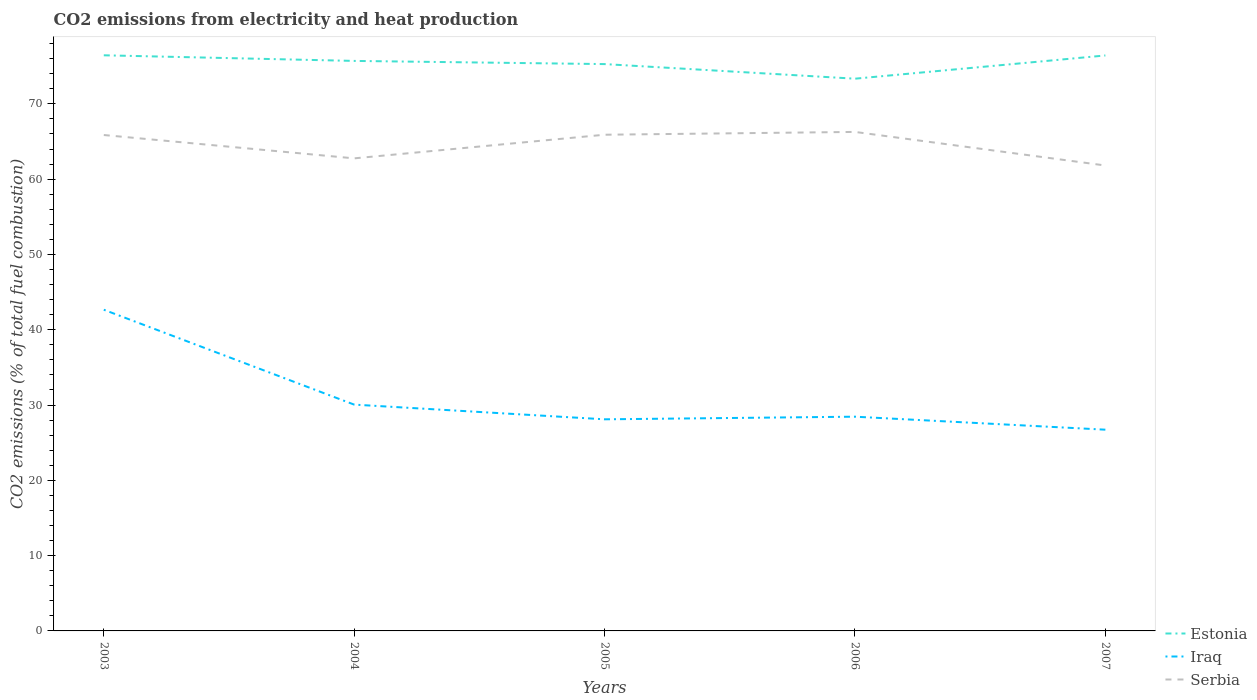How many different coloured lines are there?
Your answer should be very brief. 3. Does the line corresponding to Estonia intersect with the line corresponding to Serbia?
Offer a very short reply. No. Is the number of lines equal to the number of legend labels?
Offer a very short reply. Yes. Across all years, what is the maximum amount of CO2 emitted in Iraq?
Provide a short and direct response. 26.73. In which year was the amount of CO2 emitted in Iraq maximum?
Give a very brief answer. 2007. What is the total amount of CO2 emitted in Iraq in the graph?
Keep it short and to the point. 1.95. What is the difference between the highest and the second highest amount of CO2 emitted in Serbia?
Keep it short and to the point. 4.46. Is the amount of CO2 emitted in Iraq strictly greater than the amount of CO2 emitted in Estonia over the years?
Your response must be concise. Yes. How many years are there in the graph?
Give a very brief answer. 5. What is the difference between two consecutive major ticks on the Y-axis?
Your answer should be very brief. 10. Are the values on the major ticks of Y-axis written in scientific E-notation?
Provide a succinct answer. No. Does the graph contain any zero values?
Provide a short and direct response. No. Does the graph contain grids?
Make the answer very short. No. How are the legend labels stacked?
Offer a terse response. Vertical. What is the title of the graph?
Make the answer very short. CO2 emissions from electricity and heat production. Does "Azerbaijan" appear as one of the legend labels in the graph?
Give a very brief answer. No. What is the label or title of the Y-axis?
Offer a very short reply. CO2 emissions (% of total fuel combustion). What is the CO2 emissions (% of total fuel combustion) of Estonia in 2003?
Ensure brevity in your answer.  76.45. What is the CO2 emissions (% of total fuel combustion) in Iraq in 2003?
Your answer should be very brief. 42.66. What is the CO2 emissions (% of total fuel combustion) in Serbia in 2003?
Ensure brevity in your answer.  65.86. What is the CO2 emissions (% of total fuel combustion) in Estonia in 2004?
Make the answer very short. 75.7. What is the CO2 emissions (% of total fuel combustion) in Iraq in 2004?
Provide a short and direct response. 30.06. What is the CO2 emissions (% of total fuel combustion) in Serbia in 2004?
Make the answer very short. 62.76. What is the CO2 emissions (% of total fuel combustion) in Estonia in 2005?
Offer a terse response. 75.28. What is the CO2 emissions (% of total fuel combustion) of Iraq in 2005?
Your response must be concise. 28.1. What is the CO2 emissions (% of total fuel combustion) of Serbia in 2005?
Your answer should be very brief. 65.9. What is the CO2 emissions (% of total fuel combustion) of Estonia in 2006?
Give a very brief answer. 73.34. What is the CO2 emissions (% of total fuel combustion) in Iraq in 2006?
Make the answer very short. 28.45. What is the CO2 emissions (% of total fuel combustion) in Serbia in 2006?
Ensure brevity in your answer.  66.27. What is the CO2 emissions (% of total fuel combustion) of Estonia in 2007?
Your answer should be compact. 76.43. What is the CO2 emissions (% of total fuel combustion) in Iraq in 2007?
Your response must be concise. 26.73. What is the CO2 emissions (% of total fuel combustion) of Serbia in 2007?
Ensure brevity in your answer.  61.81. Across all years, what is the maximum CO2 emissions (% of total fuel combustion) of Estonia?
Provide a short and direct response. 76.45. Across all years, what is the maximum CO2 emissions (% of total fuel combustion) in Iraq?
Your answer should be compact. 42.66. Across all years, what is the maximum CO2 emissions (% of total fuel combustion) of Serbia?
Keep it short and to the point. 66.27. Across all years, what is the minimum CO2 emissions (% of total fuel combustion) in Estonia?
Ensure brevity in your answer.  73.34. Across all years, what is the minimum CO2 emissions (% of total fuel combustion) of Iraq?
Your response must be concise. 26.73. Across all years, what is the minimum CO2 emissions (% of total fuel combustion) in Serbia?
Offer a very short reply. 61.81. What is the total CO2 emissions (% of total fuel combustion) of Estonia in the graph?
Give a very brief answer. 377.2. What is the total CO2 emissions (% of total fuel combustion) in Iraq in the graph?
Keep it short and to the point. 156. What is the total CO2 emissions (% of total fuel combustion) in Serbia in the graph?
Your answer should be very brief. 322.61. What is the difference between the CO2 emissions (% of total fuel combustion) of Estonia in 2003 and that in 2004?
Offer a very short reply. 0.75. What is the difference between the CO2 emissions (% of total fuel combustion) of Iraq in 2003 and that in 2004?
Your answer should be compact. 12.6. What is the difference between the CO2 emissions (% of total fuel combustion) in Estonia in 2003 and that in 2005?
Ensure brevity in your answer.  1.17. What is the difference between the CO2 emissions (% of total fuel combustion) of Iraq in 2003 and that in 2005?
Your response must be concise. 14.55. What is the difference between the CO2 emissions (% of total fuel combustion) of Serbia in 2003 and that in 2005?
Provide a short and direct response. -0.04. What is the difference between the CO2 emissions (% of total fuel combustion) of Estonia in 2003 and that in 2006?
Provide a short and direct response. 3.11. What is the difference between the CO2 emissions (% of total fuel combustion) in Iraq in 2003 and that in 2006?
Make the answer very short. 14.21. What is the difference between the CO2 emissions (% of total fuel combustion) in Serbia in 2003 and that in 2006?
Offer a very short reply. -0.41. What is the difference between the CO2 emissions (% of total fuel combustion) of Estonia in 2003 and that in 2007?
Provide a succinct answer. 0.02. What is the difference between the CO2 emissions (% of total fuel combustion) of Iraq in 2003 and that in 2007?
Ensure brevity in your answer.  15.93. What is the difference between the CO2 emissions (% of total fuel combustion) in Serbia in 2003 and that in 2007?
Keep it short and to the point. 4.05. What is the difference between the CO2 emissions (% of total fuel combustion) of Estonia in 2004 and that in 2005?
Keep it short and to the point. 0.42. What is the difference between the CO2 emissions (% of total fuel combustion) of Iraq in 2004 and that in 2005?
Your response must be concise. 1.95. What is the difference between the CO2 emissions (% of total fuel combustion) in Serbia in 2004 and that in 2005?
Your answer should be compact. -3.14. What is the difference between the CO2 emissions (% of total fuel combustion) of Estonia in 2004 and that in 2006?
Offer a terse response. 2.36. What is the difference between the CO2 emissions (% of total fuel combustion) in Iraq in 2004 and that in 2006?
Your answer should be compact. 1.6. What is the difference between the CO2 emissions (% of total fuel combustion) of Serbia in 2004 and that in 2006?
Give a very brief answer. -3.51. What is the difference between the CO2 emissions (% of total fuel combustion) of Estonia in 2004 and that in 2007?
Provide a succinct answer. -0.72. What is the difference between the CO2 emissions (% of total fuel combustion) of Iraq in 2004 and that in 2007?
Provide a short and direct response. 3.33. What is the difference between the CO2 emissions (% of total fuel combustion) in Serbia in 2004 and that in 2007?
Your response must be concise. 0.95. What is the difference between the CO2 emissions (% of total fuel combustion) in Estonia in 2005 and that in 2006?
Keep it short and to the point. 1.94. What is the difference between the CO2 emissions (% of total fuel combustion) in Iraq in 2005 and that in 2006?
Offer a very short reply. -0.35. What is the difference between the CO2 emissions (% of total fuel combustion) of Serbia in 2005 and that in 2006?
Your response must be concise. -0.37. What is the difference between the CO2 emissions (% of total fuel combustion) of Estonia in 2005 and that in 2007?
Give a very brief answer. -1.15. What is the difference between the CO2 emissions (% of total fuel combustion) in Iraq in 2005 and that in 2007?
Give a very brief answer. 1.38. What is the difference between the CO2 emissions (% of total fuel combustion) in Serbia in 2005 and that in 2007?
Ensure brevity in your answer.  4.09. What is the difference between the CO2 emissions (% of total fuel combustion) of Estonia in 2006 and that in 2007?
Offer a very short reply. -3.09. What is the difference between the CO2 emissions (% of total fuel combustion) in Iraq in 2006 and that in 2007?
Offer a terse response. 1.73. What is the difference between the CO2 emissions (% of total fuel combustion) in Serbia in 2006 and that in 2007?
Provide a succinct answer. 4.46. What is the difference between the CO2 emissions (% of total fuel combustion) in Estonia in 2003 and the CO2 emissions (% of total fuel combustion) in Iraq in 2004?
Your answer should be very brief. 46.39. What is the difference between the CO2 emissions (% of total fuel combustion) in Estonia in 2003 and the CO2 emissions (% of total fuel combustion) in Serbia in 2004?
Offer a very short reply. 13.69. What is the difference between the CO2 emissions (% of total fuel combustion) of Iraq in 2003 and the CO2 emissions (% of total fuel combustion) of Serbia in 2004?
Give a very brief answer. -20.1. What is the difference between the CO2 emissions (% of total fuel combustion) of Estonia in 2003 and the CO2 emissions (% of total fuel combustion) of Iraq in 2005?
Your answer should be very brief. 48.35. What is the difference between the CO2 emissions (% of total fuel combustion) in Estonia in 2003 and the CO2 emissions (% of total fuel combustion) in Serbia in 2005?
Give a very brief answer. 10.55. What is the difference between the CO2 emissions (% of total fuel combustion) in Iraq in 2003 and the CO2 emissions (% of total fuel combustion) in Serbia in 2005?
Your answer should be compact. -23.24. What is the difference between the CO2 emissions (% of total fuel combustion) of Estonia in 2003 and the CO2 emissions (% of total fuel combustion) of Iraq in 2006?
Your answer should be very brief. 48. What is the difference between the CO2 emissions (% of total fuel combustion) of Estonia in 2003 and the CO2 emissions (% of total fuel combustion) of Serbia in 2006?
Your answer should be very brief. 10.18. What is the difference between the CO2 emissions (% of total fuel combustion) of Iraq in 2003 and the CO2 emissions (% of total fuel combustion) of Serbia in 2006?
Keep it short and to the point. -23.61. What is the difference between the CO2 emissions (% of total fuel combustion) in Estonia in 2003 and the CO2 emissions (% of total fuel combustion) in Iraq in 2007?
Provide a succinct answer. 49.72. What is the difference between the CO2 emissions (% of total fuel combustion) of Estonia in 2003 and the CO2 emissions (% of total fuel combustion) of Serbia in 2007?
Your response must be concise. 14.64. What is the difference between the CO2 emissions (% of total fuel combustion) in Iraq in 2003 and the CO2 emissions (% of total fuel combustion) in Serbia in 2007?
Keep it short and to the point. -19.15. What is the difference between the CO2 emissions (% of total fuel combustion) of Estonia in 2004 and the CO2 emissions (% of total fuel combustion) of Iraq in 2005?
Your answer should be compact. 47.6. What is the difference between the CO2 emissions (% of total fuel combustion) of Estonia in 2004 and the CO2 emissions (% of total fuel combustion) of Serbia in 2005?
Ensure brevity in your answer.  9.8. What is the difference between the CO2 emissions (% of total fuel combustion) in Iraq in 2004 and the CO2 emissions (% of total fuel combustion) in Serbia in 2005?
Offer a terse response. -35.84. What is the difference between the CO2 emissions (% of total fuel combustion) in Estonia in 2004 and the CO2 emissions (% of total fuel combustion) in Iraq in 2006?
Provide a succinct answer. 47.25. What is the difference between the CO2 emissions (% of total fuel combustion) of Estonia in 2004 and the CO2 emissions (% of total fuel combustion) of Serbia in 2006?
Your answer should be very brief. 9.43. What is the difference between the CO2 emissions (% of total fuel combustion) in Iraq in 2004 and the CO2 emissions (% of total fuel combustion) in Serbia in 2006?
Your answer should be compact. -36.22. What is the difference between the CO2 emissions (% of total fuel combustion) in Estonia in 2004 and the CO2 emissions (% of total fuel combustion) in Iraq in 2007?
Ensure brevity in your answer.  48.98. What is the difference between the CO2 emissions (% of total fuel combustion) of Estonia in 2004 and the CO2 emissions (% of total fuel combustion) of Serbia in 2007?
Give a very brief answer. 13.89. What is the difference between the CO2 emissions (% of total fuel combustion) of Iraq in 2004 and the CO2 emissions (% of total fuel combustion) of Serbia in 2007?
Offer a very short reply. -31.76. What is the difference between the CO2 emissions (% of total fuel combustion) of Estonia in 2005 and the CO2 emissions (% of total fuel combustion) of Iraq in 2006?
Ensure brevity in your answer.  46.83. What is the difference between the CO2 emissions (% of total fuel combustion) of Estonia in 2005 and the CO2 emissions (% of total fuel combustion) of Serbia in 2006?
Provide a short and direct response. 9.01. What is the difference between the CO2 emissions (% of total fuel combustion) of Iraq in 2005 and the CO2 emissions (% of total fuel combustion) of Serbia in 2006?
Offer a terse response. -38.17. What is the difference between the CO2 emissions (% of total fuel combustion) in Estonia in 2005 and the CO2 emissions (% of total fuel combustion) in Iraq in 2007?
Offer a terse response. 48.55. What is the difference between the CO2 emissions (% of total fuel combustion) of Estonia in 2005 and the CO2 emissions (% of total fuel combustion) of Serbia in 2007?
Your response must be concise. 13.47. What is the difference between the CO2 emissions (% of total fuel combustion) of Iraq in 2005 and the CO2 emissions (% of total fuel combustion) of Serbia in 2007?
Give a very brief answer. -33.71. What is the difference between the CO2 emissions (% of total fuel combustion) of Estonia in 2006 and the CO2 emissions (% of total fuel combustion) of Iraq in 2007?
Your response must be concise. 46.62. What is the difference between the CO2 emissions (% of total fuel combustion) of Estonia in 2006 and the CO2 emissions (% of total fuel combustion) of Serbia in 2007?
Your answer should be very brief. 11.53. What is the difference between the CO2 emissions (% of total fuel combustion) of Iraq in 2006 and the CO2 emissions (% of total fuel combustion) of Serbia in 2007?
Your answer should be compact. -33.36. What is the average CO2 emissions (% of total fuel combustion) in Estonia per year?
Keep it short and to the point. 75.44. What is the average CO2 emissions (% of total fuel combustion) in Iraq per year?
Give a very brief answer. 31.2. What is the average CO2 emissions (% of total fuel combustion) in Serbia per year?
Offer a very short reply. 64.52. In the year 2003, what is the difference between the CO2 emissions (% of total fuel combustion) of Estonia and CO2 emissions (% of total fuel combustion) of Iraq?
Your answer should be very brief. 33.79. In the year 2003, what is the difference between the CO2 emissions (% of total fuel combustion) of Estonia and CO2 emissions (% of total fuel combustion) of Serbia?
Provide a succinct answer. 10.59. In the year 2003, what is the difference between the CO2 emissions (% of total fuel combustion) in Iraq and CO2 emissions (% of total fuel combustion) in Serbia?
Provide a short and direct response. -23.2. In the year 2004, what is the difference between the CO2 emissions (% of total fuel combustion) of Estonia and CO2 emissions (% of total fuel combustion) of Iraq?
Keep it short and to the point. 45.65. In the year 2004, what is the difference between the CO2 emissions (% of total fuel combustion) in Estonia and CO2 emissions (% of total fuel combustion) in Serbia?
Provide a succinct answer. 12.94. In the year 2004, what is the difference between the CO2 emissions (% of total fuel combustion) of Iraq and CO2 emissions (% of total fuel combustion) of Serbia?
Your response must be concise. -32.71. In the year 2005, what is the difference between the CO2 emissions (% of total fuel combustion) of Estonia and CO2 emissions (% of total fuel combustion) of Iraq?
Your response must be concise. 47.18. In the year 2005, what is the difference between the CO2 emissions (% of total fuel combustion) in Estonia and CO2 emissions (% of total fuel combustion) in Serbia?
Keep it short and to the point. 9.38. In the year 2005, what is the difference between the CO2 emissions (% of total fuel combustion) in Iraq and CO2 emissions (% of total fuel combustion) in Serbia?
Give a very brief answer. -37.8. In the year 2006, what is the difference between the CO2 emissions (% of total fuel combustion) in Estonia and CO2 emissions (% of total fuel combustion) in Iraq?
Ensure brevity in your answer.  44.89. In the year 2006, what is the difference between the CO2 emissions (% of total fuel combustion) in Estonia and CO2 emissions (% of total fuel combustion) in Serbia?
Your response must be concise. 7.07. In the year 2006, what is the difference between the CO2 emissions (% of total fuel combustion) of Iraq and CO2 emissions (% of total fuel combustion) of Serbia?
Your answer should be compact. -37.82. In the year 2007, what is the difference between the CO2 emissions (% of total fuel combustion) of Estonia and CO2 emissions (% of total fuel combustion) of Iraq?
Your response must be concise. 49.7. In the year 2007, what is the difference between the CO2 emissions (% of total fuel combustion) in Estonia and CO2 emissions (% of total fuel combustion) in Serbia?
Provide a succinct answer. 14.62. In the year 2007, what is the difference between the CO2 emissions (% of total fuel combustion) of Iraq and CO2 emissions (% of total fuel combustion) of Serbia?
Offer a very short reply. -35.09. What is the ratio of the CO2 emissions (% of total fuel combustion) of Estonia in 2003 to that in 2004?
Provide a short and direct response. 1.01. What is the ratio of the CO2 emissions (% of total fuel combustion) in Iraq in 2003 to that in 2004?
Ensure brevity in your answer.  1.42. What is the ratio of the CO2 emissions (% of total fuel combustion) of Serbia in 2003 to that in 2004?
Ensure brevity in your answer.  1.05. What is the ratio of the CO2 emissions (% of total fuel combustion) of Estonia in 2003 to that in 2005?
Offer a very short reply. 1.02. What is the ratio of the CO2 emissions (% of total fuel combustion) in Iraq in 2003 to that in 2005?
Offer a very short reply. 1.52. What is the ratio of the CO2 emissions (% of total fuel combustion) in Serbia in 2003 to that in 2005?
Your response must be concise. 1. What is the ratio of the CO2 emissions (% of total fuel combustion) of Estonia in 2003 to that in 2006?
Provide a succinct answer. 1.04. What is the ratio of the CO2 emissions (% of total fuel combustion) of Iraq in 2003 to that in 2006?
Offer a terse response. 1.5. What is the ratio of the CO2 emissions (% of total fuel combustion) in Estonia in 2003 to that in 2007?
Keep it short and to the point. 1. What is the ratio of the CO2 emissions (% of total fuel combustion) in Iraq in 2003 to that in 2007?
Give a very brief answer. 1.6. What is the ratio of the CO2 emissions (% of total fuel combustion) of Serbia in 2003 to that in 2007?
Your response must be concise. 1.07. What is the ratio of the CO2 emissions (% of total fuel combustion) of Estonia in 2004 to that in 2005?
Give a very brief answer. 1.01. What is the ratio of the CO2 emissions (% of total fuel combustion) in Iraq in 2004 to that in 2005?
Give a very brief answer. 1.07. What is the ratio of the CO2 emissions (% of total fuel combustion) of Estonia in 2004 to that in 2006?
Give a very brief answer. 1.03. What is the ratio of the CO2 emissions (% of total fuel combustion) of Iraq in 2004 to that in 2006?
Your response must be concise. 1.06. What is the ratio of the CO2 emissions (% of total fuel combustion) in Serbia in 2004 to that in 2006?
Offer a terse response. 0.95. What is the ratio of the CO2 emissions (% of total fuel combustion) of Iraq in 2004 to that in 2007?
Your answer should be compact. 1.12. What is the ratio of the CO2 emissions (% of total fuel combustion) in Serbia in 2004 to that in 2007?
Your response must be concise. 1.02. What is the ratio of the CO2 emissions (% of total fuel combustion) in Estonia in 2005 to that in 2006?
Offer a very short reply. 1.03. What is the ratio of the CO2 emissions (% of total fuel combustion) in Iraq in 2005 to that in 2006?
Provide a short and direct response. 0.99. What is the ratio of the CO2 emissions (% of total fuel combustion) of Serbia in 2005 to that in 2006?
Ensure brevity in your answer.  0.99. What is the ratio of the CO2 emissions (% of total fuel combustion) in Iraq in 2005 to that in 2007?
Give a very brief answer. 1.05. What is the ratio of the CO2 emissions (% of total fuel combustion) in Serbia in 2005 to that in 2007?
Your answer should be compact. 1.07. What is the ratio of the CO2 emissions (% of total fuel combustion) in Estonia in 2006 to that in 2007?
Provide a succinct answer. 0.96. What is the ratio of the CO2 emissions (% of total fuel combustion) in Iraq in 2006 to that in 2007?
Your response must be concise. 1.06. What is the ratio of the CO2 emissions (% of total fuel combustion) of Serbia in 2006 to that in 2007?
Your answer should be compact. 1.07. What is the difference between the highest and the second highest CO2 emissions (% of total fuel combustion) of Estonia?
Make the answer very short. 0.02. What is the difference between the highest and the second highest CO2 emissions (% of total fuel combustion) in Iraq?
Your answer should be compact. 12.6. What is the difference between the highest and the second highest CO2 emissions (% of total fuel combustion) in Serbia?
Provide a succinct answer. 0.37. What is the difference between the highest and the lowest CO2 emissions (% of total fuel combustion) in Estonia?
Your response must be concise. 3.11. What is the difference between the highest and the lowest CO2 emissions (% of total fuel combustion) of Iraq?
Make the answer very short. 15.93. What is the difference between the highest and the lowest CO2 emissions (% of total fuel combustion) of Serbia?
Ensure brevity in your answer.  4.46. 